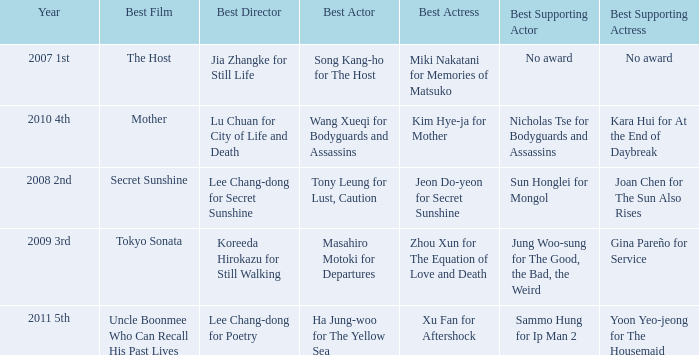Name the best actor for uncle boonmee who can recall his past lives Ha Jung-woo for The Yellow Sea. 